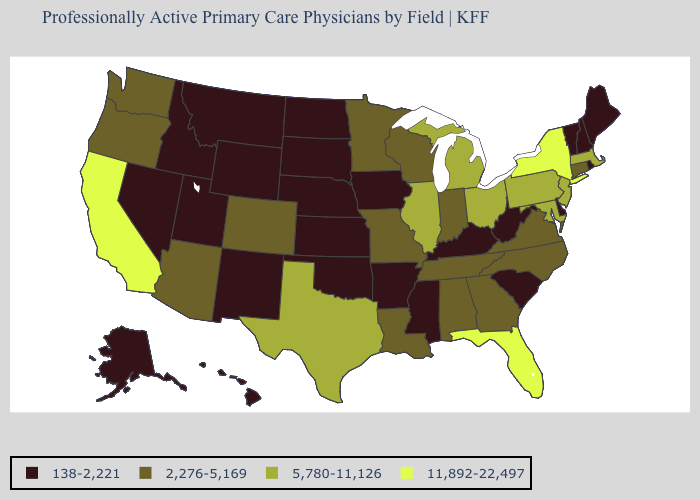Name the states that have a value in the range 5,780-11,126?
Answer briefly. Illinois, Maryland, Massachusetts, Michigan, New Jersey, Ohio, Pennsylvania, Texas. What is the value of Arkansas?
Answer briefly. 138-2,221. What is the value of Connecticut?
Give a very brief answer. 2,276-5,169. What is the value of Massachusetts?
Be succinct. 5,780-11,126. Does Kentucky have the lowest value in the South?
Give a very brief answer. Yes. How many symbols are there in the legend?
Give a very brief answer. 4. Name the states that have a value in the range 5,780-11,126?
Concise answer only. Illinois, Maryland, Massachusetts, Michigan, New Jersey, Ohio, Pennsylvania, Texas. What is the lowest value in the South?
Keep it brief. 138-2,221. Name the states that have a value in the range 138-2,221?
Keep it brief. Alaska, Arkansas, Delaware, Hawaii, Idaho, Iowa, Kansas, Kentucky, Maine, Mississippi, Montana, Nebraska, Nevada, New Hampshire, New Mexico, North Dakota, Oklahoma, Rhode Island, South Carolina, South Dakota, Utah, Vermont, West Virginia, Wyoming. What is the value of Vermont?
Short answer required. 138-2,221. Which states hav the highest value in the West?
Be succinct. California. What is the value of Minnesota?
Answer briefly. 2,276-5,169. Which states hav the highest value in the MidWest?
Answer briefly. Illinois, Michigan, Ohio. Name the states that have a value in the range 2,276-5,169?
Give a very brief answer. Alabama, Arizona, Colorado, Connecticut, Georgia, Indiana, Louisiana, Minnesota, Missouri, North Carolina, Oregon, Tennessee, Virginia, Washington, Wisconsin. Does Illinois have a lower value than California?
Short answer required. Yes. 